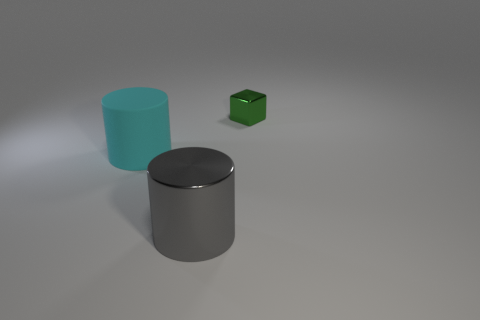The other cylinder that is the same size as the gray cylinder is what color?
Offer a very short reply. Cyan. Are the cylinder in front of the cyan matte cylinder and the thing left of the metal cylinder made of the same material?
Make the answer very short. No. There is a cylinder on the left side of the metallic object in front of the green metal thing; how big is it?
Your answer should be compact. Large. There is a large thing right of the large cyan thing; what is its material?
Ensure brevity in your answer.  Metal. How many objects are either metal things that are in front of the tiny block or shiny things that are behind the large gray cylinder?
Give a very brief answer. 2. What material is the other large object that is the same shape as the matte object?
Offer a very short reply. Metal. There is a shiny thing that is to the left of the green metal thing; is its color the same as the object behind the large cyan rubber cylinder?
Offer a very short reply. No. Are there any gray metallic cylinders of the same size as the rubber object?
Make the answer very short. Yes. What material is the thing that is both behind the gray cylinder and to the left of the tiny green metal thing?
Give a very brief answer. Rubber. How many matte objects are either tiny blue spheres or small cubes?
Provide a succinct answer. 0. 